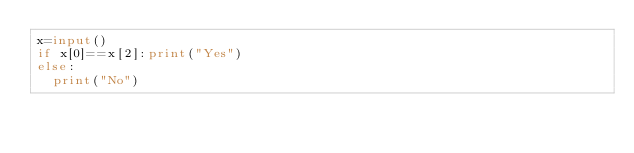Convert code to text. <code><loc_0><loc_0><loc_500><loc_500><_Python_>x=input()
if x[0]==x[2]:print("Yes")
else:
  print("No")</code> 